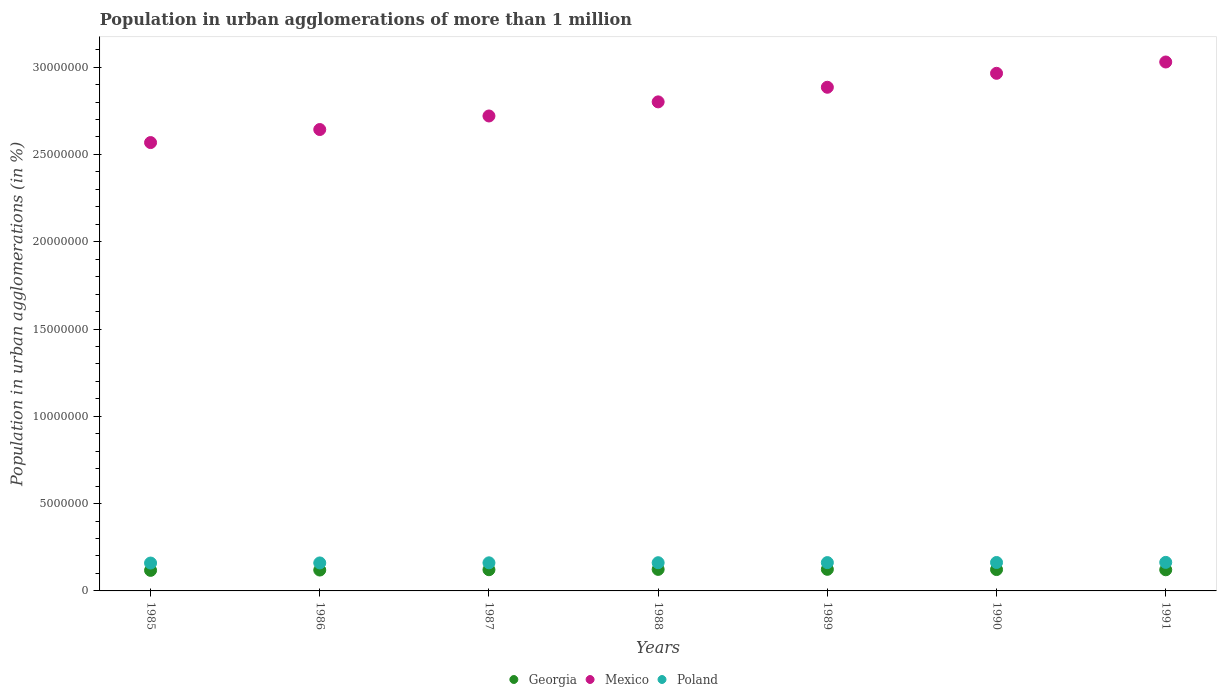How many different coloured dotlines are there?
Keep it short and to the point. 3. What is the population in urban agglomerations in Mexico in 1985?
Your answer should be compact. 2.57e+07. Across all years, what is the maximum population in urban agglomerations in Mexico?
Provide a short and direct response. 3.03e+07. Across all years, what is the minimum population in urban agglomerations in Poland?
Provide a short and direct response. 1.60e+06. In which year was the population in urban agglomerations in Poland maximum?
Your answer should be very brief. 1991. What is the total population in urban agglomerations in Georgia in the graph?
Your answer should be compact. 8.49e+06. What is the difference between the population in urban agglomerations in Mexico in 1988 and that in 1991?
Keep it short and to the point. -2.28e+06. What is the difference between the population in urban agglomerations in Poland in 1989 and the population in urban agglomerations in Mexico in 1987?
Keep it short and to the point. -2.56e+07. What is the average population in urban agglomerations in Poland per year?
Provide a short and direct response. 1.62e+06. In the year 1990, what is the difference between the population in urban agglomerations in Georgia and population in urban agglomerations in Mexico?
Ensure brevity in your answer.  -2.84e+07. What is the ratio of the population in urban agglomerations in Poland in 1989 to that in 1990?
Provide a short and direct response. 1. Is the difference between the population in urban agglomerations in Georgia in 1989 and 1991 greater than the difference between the population in urban agglomerations in Mexico in 1989 and 1991?
Offer a terse response. Yes. What is the difference between the highest and the second highest population in urban agglomerations in Mexico?
Give a very brief answer. 6.48e+05. What is the difference between the highest and the lowest population in urban agglomerations in Georgia?
Your answer should be compact. 5.96e+04. In how many years, is the population in urban agglomerations in Poland greater than the average population in urban agglomerations in Poland taken over all years?
Ensure brevity in your answer.  3. Is the sum of the population in urban agglomerations in Georgia in 1986 and 1989 greater than the maximum population in urban agglomerations in Mexico across all years?
Keep it short and to the point. No. Is it the case that in every year, the sum of the population in urban agglomerations in Poland and population in urban agglomerations in Georgia  is greater than the population in urban agglomerations in Mexico?
Provide a short and direct response. No. Does the population in urban agglomerations in Poland monotonically increase over the years?
Provide a succinct answer. Yes. Is the population in urban agglomerations in Georgia strictly less than the population in urban agglomerations in Poland over the years?
Make the answer very short. Yes. How many dotlines are there?
Ensure brevity in your answer.  3. How many years are there in the graph?
Your response must be concise. 7. Are the values on the major ticks of Y-axis written in scientific E-notation?
Your response must be concise. No. Does the graph contain any zero values?
Your response must be concise. No. Does the graph contain grids?
Offer a very short reply. No. Where does the legend appear in the graph?
Provide a succinct answer. Bottom center. How many legend labels are there?
Your response must be concise. 3. How are the legend labels stacked?
Make the answer very short. Horizontal. What is the title of the graph?
Your answer should be compact. Population in urban agglomerations of more than 1 million. Does "Latin America(developing only)" appear as one of the legend labels in the graph?
Offer a terse response. No. What is the label or title of the X-axis?
Offer a terse response. Years. What is the label or title of the Y-axis?
Your answer should be very brief. Population in urban agglomerations (in %). What is the Population in urban agglomerations (in %) in Georgia in 1985?
Your answer should be compact. 1.18e+06. What is the Population in urban agglomerations (in %) of Mexico in 1985?
Provide a succinct answer. 2.57e+07. What is the Population in urban agglomerations (in %) of Poland in 1985?
Your answer should be very brief. 1.60e+06. What is the Population in urban agglomerations (in %) of Georgia in 1986?
Offer a terse response. 1.20e+06. What is the Population in urban agglomerations (in %) in Mexico in 1986?
Give a very brief answer. 2.64e+07. What is the Population in urban agglomerations (in %) in Poland in 1986?
Offer a terse response. 1.60e+06. What is the Population in urban agglomerations (in %) in Georgia in 1987?
Provide a succinct answer. 1.21e+06. What is the Population in urban agglomerations (in %) of Mexico in 1987?
Provide a succinct answer. 2.72e+07. What is the Population in urban agglomerations (in %) in Poland in 1987?
Your response must be concise. 1.61e+06. What is the Population in urban agglomerations (in %) of Georgia in 1988?
Your response must be concise. 1.23e+06. What is the Population in urban agglomerations (in %) in Mexico in 1988?
Keep it short and to the point. 2.80e+07. What is the Population in urban agglomerations (in %) of Poland in 1988?
Offer a terse response. 1.62e+06. What is the Population in urban agglomerations (in %) of Georgia in 1989?
Keep it short and to the point. 1.24e+06. What is the Population in urban agglomerations (in %) of Mexico in 1989?
Give a very brief answer. 2.88e+07. What is the Population in urban agglomerations (in %) in Poland in 1989?
Give a very brief answer. 1.62e+06. What is the Population in urban agglomerations (in %) of Georgia in 1990?
Make the answer very short. 1.22e+06. What is the Population in urban agglomerations (in %) in Mexico in 1990?
Your response must be concise. 2.96e+07. What is the Population in urban agglomerations (in %) in Poland in 1990?
Provide a succinct answer. 1.63e+06. What is the Population in urban agglomerations (in %) in Georgia in 1991?
Give a very brief answer. 1.21e+06. What is the Population in urban agglomerations (in %) in Mexico in 1991?
Ensure brevity in your answer.  3.03e+07. What is the Population in urban agglomerations (in %) in Poland in 1991?
Your answer should be compact. 1.63e+06. Across all years, what is the maximum Population in urban agglomerations (in %) of Georgia?
Your answer should be compact. 1.24e+06. Across all years, what is the maximum Population in urban agglomerations (in %) in Mexico?
Keep it short and to the point. 3.03e+07. Across all years, what is the maximum Population in urban agglomerations (in %) of Poland?
Make the answer very short. 1.63e+06. Across all years, what is the minimum Population in urban agglomerations (in %) in Georgia?
Offer a terse response. 1.18e+06. Across all years, what is the minimum Population in urban agglomerations (in %) of Mexico?
Make the answer very short. 2.57e+07. Across all years, what is the minimum Population in urban agglomerations (in %) in Poland?
Offer a terse response. 1.60e+06. What is the total Population in urban agglomerations (in %) of Georgia in the graph?
Provide a succinct answer. 8.49e+06. What is the total Population in urban agglomerations (in %) in Mexico in the graph?
Offer a very short reply. 1.96e+08. What is the total Population in urban agglomerations (in %) of Poland in the graph?
Keep it short and to the point. 1.13e+07. What is the difference between the Population in urban agglomerations (in %) in Georgia in 1985 and that in 1986?
Offer a very short reply. -1.83e+04. What is the difference between the Population in urban agglomerations (in %) in Mexico in 1985 and that in 1986?
Give a very brief answer. -7.47e+05. What is the difference between the Population in urban agglomerations (in %) of Poland in 1985 and that in 1986?
Your answer should be compact. -6335. What is the difference between the Population in urban agglomerations (in %) of Georgia in 1985 and that in 1987?
Your answer should be compact. -3.68e+04. What is the difference between the Population in urban agglomerations (in %) of Mexico in 1985 and that in 1987?
Make the answer very short. -1.52e+06. What is the difference between the Population in urban agglomerations (in %) of Poland in 1985 and that in 1987?
Your response must be concise. -1.27e+04. What is the difference between the Population in urban agglomerations (in %) in Georgia in 1985 and that in 1988?
Your response must be concise. -5.56e+04. What is the difference between the Population in urban agglomerations (in %) in Mexico in 1985 and that in 1988?
Ensure brevity in your answer.  -2.33e+06. What is the difference between the Population in urban agglomerations (in %) in Poland in 1985 and that in 1988?
Offer a very short reply. -1.91e+04. What is the difference between the Population in urban agglomerations (in %) of Georgia in 1985 and that in 1989?
Your answer should be very brief. -5.96e+04. What is the difference between the Population in urban agglomerations (in %) in Mexico in 1985 and that in 1989?
Your answer should be very brief. -3.17e+06. What is the difference between the Population in urban agglomerations (in %) in Poland in 1985 and that in 1989?
Make the answer very short. -2.55e+04. What is the difference between the Population in urban agglomerations (in %) in Georgia in 1985 and that in 1990?
Your answer should be compact. -4.65e+04. What is the difference between the Population in urban agglomerations (in %) of Mexico in 1985 and that in 1990?
Offer a terse response. -3.97e+06. What is the difference between the Population in urban agglomerations (in %) in Poland in 1985 and that in 1990?
Give a very brief answer. -3.19e+04. What is the difference between the Population in urban agglomerations (in %) of Georgia in 1985 and that in 1991?
Give a very brief answer. -3.35e+04. What is the difference between the Population in urban agglomerations (in %) of Mexico in 1985 and that in 1991?
Provide a succinct answer. -4.61e+06. What is the difference between the Population in urban agglomerations (in %) in Poland in 1985 and that in 1991?
Your answer should be compact. -3.84e+04. What is the difference between the Population in urban agglomerations (in %) in Georgia in 1986 and that in 1987?
Offer a terse response. -1.85e+04. What is the difference between the Population in urban agglomerations (in %) of Mexico in 1986 and that in 1987?
Your answer should be very brief. -7.76e+05. What is the difference between the Population in urban agglomerations (in %) in Poland in 1986 and that in 1987?
Your answer should be compact. -6361. What is the difference between the Population in urban agglomerations (in %) in Georgia in 1986 and that in 1988?
Provide a succinct answer. -3.74e+04. What is the difference between the Population in urban agglomerations (in %) in Mexico in 1986 and that in 1988?
Make the answer very short. -1.58e+06. What is the difference between the Population in urban agglomerations (in %) in Poland in 1986 and that in 1988?
Make the answer very short. -1.28e+04. What is the difference between the Population in urban agglomerations (in %) of Georgia in 1986 and that in 1989?
Provide a succinct answer. -4.14e+04. What is the difference between the Population in urban agglomerations (in %) in Mexico in 1986 and that in 1989?
Provide a short and direct response. -2.42e+06. What is the difference between the Population in urban agglomerations (in %) of Poland in 1986 and that in 1989?
Offer a terse response. -1.92e+04. What is the difference between the Population in urban agglomerations (in %) in Georgia in 1986 and that in 1990?
Provide a short and direct response. -2.82e+04. What is the difference between the Population in urban agglomerations (in %) of Mexico in 1986 and that in 1990?
Your answer should be compact. -3.22e+06. What is the difference between the Population in urban agglomerations (in %) in Poland in 1986 and that in 1990?
Provide a succinct answer. -2.56e+04. What is the difference between the Population in urban agglomerations (in %) of Georgia in 1986 and that in 1991?
Keep it short and to the point. -1.52e+04. What is the difference between the Population in urban agglomerations (in %) in Mexico in 1986 and that in 1991?
Give a very brief answer. -3.87e+06. What is the difference between the Population in urban agglomerations (in %) in Poland in 1986 and that in 1991?
Give a very brief answer. -3.21e+04. What is the difference between the Population in urban agglomerations (in %) in Georgia in 1987 and that in 1988?
Give a very brief answer. -1.89e+04. What is the difference between the Population in urban agglomerations (in %) in Mexico in 1987 and that in 1988?
Keep it short and to the point. -8.07e+05. What is the difference between the Population in urban agglomerations (in %) in Poland in 1987 and that in 1988?
Offer a terse response. -6394. What is the difference between the Population in urban agglomerations (in %) in Georgia in 1987 and that in 1989?
Provide a short and direct response. -2.28e+04. What is the difference between the Population in urban agglomerations (in %) in Mexico in 1987 and that in 1989?
Provide a succinct answer. -1.64e+06. What is the difference between the Population in urban agglomerations (in %) in Poland in 1987 and that in 1989?
Your response must be concise. -1.28e+04. What is the difference between the Population in urban agglomerations (in %) in Georgia in 1987 and that in 1990?
Ensure brevity in your answer.  -9685. What is the difference between the Population in urban agglomerations (in %) of Mexico in 1987 and that in 1990?
Give a very brief answer. -2.44e+06. What is the difference between the Population in urban agglomerations (in %) of Poland in 1987 and that in 1990?
Offer a terse response. -1.92e+04. What is the difference between the Population in urban agglomerations (in %) in Georgia in 1987 and that in 1991?
Your answer should be compact. 3322. What is the difference between the Population in urban agglomerations (in %) of Mexico in 1987 and that in 1991?
Ensure brevity in your answer.  -3.09e+06. What is the difference between the Population in urban agglomerations (in %) of Poland in 1987 and that in 1991?
Ensure brevity in your answer.  -2.57e+04. What is the difference between the Population in urban agglomerations (in %) in Georgia in 1988 and that in 1989?
Provide a succinct answer. -3980. What is the difference between the Population in urban agglomerations (in %) of Mexico in 1988 and that in 1989?
Your response must be concise. -8.37e+05. What is the difference between the Population in urban agglomerations (in %) of Poland in 1988 and that in 1989?
Make the answer very short. -6402. What is the difference between the Population in urban agglomerations (in %) in Georgia in 1988 and that in 1990?
Your answer should be very brief. 9166. What is the difference between the Population in urban agglomerations (in %) in Mexico in 1988 and that in 1990?
Ensure brevity in your answer.  -1.64e+06. What is the difference between the Population in urban agglomerations (in %) in Poland in 1988 and that in 1990?
Offer a very short reply. -1.28e+04. What is the difference between the Population in urban agglomerations (in %) of Georgia in 1988 and that in 1991?
Ensure brevity in your answer.  2.22e+04. What is the difference between the Population in urban agglomerations (in %) of Mexico in 1988 and that in 1991?
Provide a succinct answer. -2.28e+06. What is the difference between the Population in urban agglomerations (in %) in Poland in 1988 and that in 1991?
Offer a terse response. -1.93e+04. What is the difference between the Population in urban agglomerations (in %) of Georgia in 1989 and that in 1990?
Your answer should be compact. 1.31e+04. What is the difference between the Population in urban agglomerations (in %) of Mexico in 1989 and that in 1990?
Your response must be concise. -7.99e+05. What is the difference between the Population in urban agglomerations (in %) of Poland in 1989 and that in 1990?
Your response must be concise. -6436. What is the difference between the Population in urban agglomerations (in %) in Georgia in 1989 and that in 1991?
Provide a short and direct response. 2.62e+04. What is the difference between the Population in urban agglomerations (in %) of Mexico in 1989 and that in 1991?
Ensure brevity in your answer.  -1.45e+06. What is the difference between the Population in urban agglomerations (in %) of Poland in 1989 and that in 1991?
Your response must be concise. -1.29e+04. What is the difference between the Population in urban agglomerations (in %) in Georgia in 1990 and that in 1991?
Make the answer very short. 1.30e+04. What is the difference between the Population in urban agglomerations (in %) in Mexico in 1990 and that in 1991?
Your answer should be compact. -6.48e+05. What is the difference between the Population in urban agglomerations (in %) of Poland in 1990 and that in 1991?
Ensure brevity in your answer.  -6462. What is the difference between the Population in urban agglomerations (in %) of Georgia in 1985 and the Population in urban agglomerations (in %) of Mexico in 1986?
Keep it short and to the point. -2.52e+07. What is the difference between the Population in urban agglomerations (in %) of Georgia in 1985 and the Population in urban agglomerations (in %) of Poland in 1986?
Provide a succinct answer. -4.25e+05. What is the difference between the Population in urban agglomerations (in %) in Mexico in 1985 and the Population in urban agglomerations (in %) in Poland in 1986?
Your answer should be very brief. 2.41e+07. What is the difference between the Population in urban agglomerations (in %) of Georgia in 1985 and the Population in urban agglomerations (in %) of Mexico in 1987?
Your answer should be very brief. -2.60e+07. What is the difference between the Population in urban agglomerations (in %) of Georgia in 1985 and the Population in urban agglomerations (in %) of Poland in 1987?
Your answer should be compact. -4.32e+05. What is the difference between the Population in urban agglomerations (in %) of Mexico in 1985 and the Population in urban agglomerations (in %) of Poland in 1987?
Your response must be concise. 2.41e+07. What is the difference between the Population in urban agglomerations (in %) in Georgia in 1985 and the Population in urban agglomerations (in %) in Mexico in 1988?
Keep it short and to the point. -2.68e+07. What is the difference between the Population in urban agglomerations (in %) in Georgia in 1985 and the Population in urban agglomerations (in %) in Poland in 1988?
Ensure brevity in your answer.  -4.38e+05. What is the difference between the Population in urban agglomerations (in %) of Mexico in 1985 and the Population in urban agglomerations (in %) of Poland in 1988?
Offer a very short reply. 2.41e+07. What is the difference between the Population in urban agglomerations (in %) in Georgia in 1985 and the Population in urban agglomerations (in %) in Mexico in 1989?
Offer a very short reply. -2.77e+07. What is the difference between the Population in urban agglomerations (in %) in Georgia in 1985 and the Population in urban agglomerations (in %) in Poland in 1989?
Provide a succinct answer. -4.45e+05. What is the difference between the Population in urban agglomerations (in %) of Mexico in 1985 and the Population in urban agglomerations (in %) of Poland in 1989?
Your answer should be very brief. 2.41e+07. What is the difference between the Population in urban agglomerations (in %) in Georgia in 1985 and the Population in urban agglomerations (in %) in Mexico in 1990?
Ensure brevity in your answer.  -2.85e+07. What is the difference between the Population in urban agglomerations (in %) in Georgia in 1985 and the Population in urban agglomerations (in %) in Poland in 1990?
Provide a succinct answer. -4.51e+05. What is the difference between the Population in urban agglomerations (in %) in Mexico in 1985 and the Population in urban agglomerations (in %) in Poland in 1990?
Keep it short and to the point. 2.40e+07. What is the difference between the Population in urban agglomerations (in %) of Georgia in 1985 and the Population in urban agglomerations (in %) of Mexico in 1991?
Provide a short and direct response. -2.91e+07. What is the difference between the Population in urban agglomerations (in %) of Georgia in 1985 and the Population in urban agglomerations (in %) of Poland in 1991?
Provide a short and direct response. -4.57e+05. What is the difference between the Population in urban agglomerations (in %) in Mexico in 1985 and the Population in urban agglomerations (in %) in Poland in 1991?
Offer a terse response. 2.40e+07. What is the difference between the Population in urban agglomerations (in %) in Georgia in 1986 and the Population in urban agglomerations (in %) in Mexico in 1987?
Offer a very short reply. -2.60e+07. What is the difference between the Population in urban agglomerations (in %) in Georgia in 1986 and the Population in urban agglomerations (in %) in Poland in 1987?
Make the answer very short. -4.13e+05. What is the difference between the Population in urban agglomerations (in %) in Mexico in 1986 and the Population in urban agglomerations (in %) in Poland in 1987?
Make the answer very short. 2.48e+07. What is the difference between the Population in urban agglomerations (in %) of Georgia in 1986 and the Population in urban agglomerations (in %) of Mexico in 1988?
Make the answer very short. -2.68e+07. What is the difference between the Population in urban agglomerations (in %) of Georgia in 1986 and the Population in urban agglomerations (in %) of Poland in 1988?
Provide a short and direct response. -4.20e+05. What is the difference between the Population in urban agglomerations (in %) of Mexico in 1986 and the Population in urban agglomerations (in %) of Poland in 1988?
Your answer should be compact. 2.48e+07. What is the difference between the Population in urban agglomerations (in %) in Georgia in 1986 and the Population in urban agglomerations (in %) in Mexico in 1989?
Make the answer very short. -2.76e+07. What is the difference between the Population in urban agglomerations (in %) of Georgia in 1986 and the Population in urban agglomerations (in %) of Poland in 1989?
Your answer should be very brief. -4.26e+05. What is the difference between the Population in urban agglomerations (in %) of Mexico in 1986 and the Population in urban agglomerations (in %) of Poland in 1989?
Provide a short and direct response. 2.48e+07. What is the difference between the Population in urban agglomerations (in %) in Georgia in 1986 and the Population in urban agglomerations (in %) in Mexico in 1990?
Keep it short and to the point. -2.84e+07. What is the difference between the Population in urban agglomerations (in %) in Georgia in 1986 and the Population in urban agglomerations (in %) in Poland in 1990?
Your answer should be compact. -4.33e+05. What is the difference between the Population in urban agglomerations (in %) of Mexico in 1986 and the Population in urban agglomerations (in %) of Poland in 1990?
Provide a short and direct response. 2.48e+07. What is the difference between the Population in urban agglomerations (in %) of Georgia in 1986 and the Population in urban agglomerations (in %) of Mexico in 1991?
Your answer should be very brief. -2.91e+07. What is the difference between the Population in urban agglomerations (in %) of Georgia in 1986 and the Population in urban agglomerations (in %) of Poland in 1991?
Make the answer very short. -4.39e+05. What is the difference between the Population in urban agglomerations (in %) in Mexico in 1986 and the Population in urban agglomerations (in %) in Poland in 1991?
Ensure brevity in your answer.  2.48e+07. What is the difference between the Population in urban agglomerations (in %) in Georgia in 1987 and the Population in urban agglomerations (in %) in Mexico in 1988?
Your response must be concise. -2.68e+07. What is the difference between the Population in urban agglomerations (in %) in Georgia in 1987 and the Population in urban agglomerations (in %) in Poland in 1988?
Keep it short and to the point. -4.01e+05. What is the difference between the Population in urban agglomerations (in %) in Mexico in 1987 and the Population in urban agglomerations (in %) in Poland in 1988?
Your answer should be very brief. 2.56e+07. What is the difference between the Population in urban agglomerations (in %) of Georgia in 1987 and the Population in urban agglomerations (in %) of Mexico in 1989?
Ensure brevity in your answer.  -2.76e+07. What is the difference between the Population in urban agglomerations (in %) in Georgia in 1987 and the Population in urban agglomerations (in %) in Poland in 1989?
Provide a short and direct response. -4.08e+05. What is the difference between the Population in urban agglomerations (in %) in Mexico in 1987 and the Population in urban agglomerations (in %) in Poland in 1989?
Provide a short and direct response. 2.56e+07. What is the difference between the Population in urban agglomerations (in %) in Georgia in 1987 and the Population in urban agglomerations (in %) in Mexico in 1990?
Ensure brevity in your answer.  -2.84e+07. What is the difference between the Population in urban agglomerations (in %) of Georgia in 1987 and the Population in urban agglomerations (in %) of Poland in 1990?
Provide a short and direct response. -4.14e+05. What is the difference between the Population in urban agglomerations (in %) in Mexico in 1987 and the Population in urban agglomerations (in %) in Poland in 1990?
Your response must be concise. 2.56e+07. What is the difference between the Population in urban agglomerations (in %) of Georgia in 1987 and the Population in urban agglomerations (in %) of Mexico in 1991?
Keep it short and to the point. -2.91e+07. What is the difference between the Population in urban agglomerations (in %) of Georgia in 1987 and the Population in urban agglomerations (in %) of Poland in 1991?
Offer a terse response. -4.21e+05. What is the difference between the Population in urban agglomerations (in %) in Mexico in 1987 and the Population in urban agglomerations (in %) in Poland in 1991?
Make the answer very short. 2.56e+07. What is the difference between the Population in urban agglomerations (in %) in Georgia in 1988 and the Population in urban agglomerations (in %) in Mexico in 1989?
Your answer should be compact. -2.76e+07. What is the difference between the Population in urban agglomerations (in %) in Georgia in 1988 and the Population in urban agglomerations (in %) in Poland in 1989?
Make the answer very short. -3.89e+05. What is the difference between the Population in urban agglomerations (in %) in Mexico in 1988 and the Population in urban agglomerations (in %) in Poland in 1989?
Offer a terse response. 2.64e+07. What is the difference between the Population in urban agglomerations (in %) of Georgia in 1988 and the Population in urban agglomerations (in %) of Mexico in 1990?
Your response must be concise. -2.84e+07. What is the difference between the Population in urban agglomerations (in %) of Georgia in 1988 and the Population in urban agglomerations (in %) of Poland in 1990?
Your answer should be very brief. -3.95e+05. What is the difference between the Population in urban agglomerations (in %) of Mexico in 1988 and the Population in urban agglomerations (in %) of Poland in 1990?
Ensure brevity in your answer.  2.64e+07. What is the difference between the Population in urban agglomerations (in %) in Georgia in 1988 and the Population in urban agglomerations (in %) in Mexico in 1991?
Provide a short and direct response. -2.91e+07. What is the difference between the Population in urban agglomerations (in %) of Georgia in 1988 and the Population in urban agglomerations (in %) of Poland in 1991?
Your answer should be very brief. -4.02e+05. What is the difference between the Population in urban agglomerations (in %) of Mexico in 1988 and the Population in urban agglomerations (in %) of Poland in 1991?
Provide a short and direct response. 2.64e+07. What is the difference between the Population in urban agglomerations (in %) of Georgia in 1989 and the Population in urban agglomerations (in %) of Mexico in 1990?
Offer a very short reply. -2.84e+07. What is the difference between the Population in urban agglomerations (in %) in Georgia in 1989 and the Population in urban agglomerations (in %) in Poland in 1990?
Offer a terse response. -3.91e+05. What is the difference between the Population in urban agglomerations (in %) in Mexico in 1989 and the Population in urban agglomerations (in %) in Poland in 1990?
Your response must be concise. 2.72e+07. What is the difference between the Population in urban agglomerations (in %) of Georgia in 1989 and the Population in urban agglomerations (in %) of Mexico in 1991?
Your response must be concise. -2.91e+07. What is the difference between the Population in urban agglomerations (in %) of Georgia in 1989 and the Population in urban agglomerations (in %) of Poland in 1991?
Make the answer very short. -3.98e+05. What is the difference between the Population in urban agglomerations (in %) in Mexico in 1989 and the Population in urban agglomerations (in %) in Poland in 1991?
Provide a short and direct response. 2.72e+07. What is the difference between the Population in urban agglomerations (in %) of Georgia in 1990 and the Population in urban agglomerations (in %) of Mexico in 1991?
Provide a succinct answer. -2.91e+07. What is the difference between the Population in urban agglomerations (in %) of Georgia in 1990 and the Population in urban agglomerations (in %) of Poland in 1991?
Offer a terse response. -4.11e+05. What is the difference between the Population in urban agglomerations (in %) in Mexico in 1990 and the Population in urban agglomerations (in %) in Poland in 1991?
Your answer should be compact. 2.80e+07. What is the average Population in urban agglomerations (in %) of Georgia per year?
Provide a succinct answer. 1.21e+06. What is the average Population in urban agglomerations (in %) of Mexico per year?
Offer a very short reply. 2.80e+07. What is the average Population in urban agglomerations (in %) in Poland per year?
Make the answer very short. 1.62e+06. In the year 1985, what is the difference between the Population in urban agglomerations (in %) of Georgia and Population in urban agglomerations (in %) of Mexico?
Your answer should be compact. -2.45e+07. In the year 1985, what is the difference between the Population in urban agglomerations (in %) in Georgia and Population in urban agglomerations (in %) in Poland?
Keep it short and to the point. -4.19e+05. In the year 1985, what is the difference between the Population in urban agglomerations (in %) of Mexico and Population in urban agglomerations (in %) of Poland?
Make the answer very short. 2.41e+07. In the year 1986, what is the difference between the Population in urban agglomerations (in %) of Georgia and Population in urban agglomerations (in %) of Mexico?
Ensure brevity in your answer.  -2.52e+07. In the year 1986, what is the difference between the Population in urban agglomerations (in %) in Georgia and Population in urban agglomerations (in %) in Poland?
Keep it short and to the point. -4.07e+05. In the year 1986, what is the difference between the Population in urban agglomerations (in %) of Mexico and Population in urban agglomerations (in %) of Poland?
Your response must be concise. 2.48e+07. In the year 1987, what is the difference between the Population in urban agglomerations (in %) of Georgia and Population in urban agglomerations (in %) of Mexico?
Keep it short and to the point. -2.60e+07. In the year 1987, what is the difference between the Population in urban agglomerations (in %) of Georgia and Population in urban agglomerations (in %) of Poland?
Offer a very short reply. -3.95e+05. In the year 1987, what is the difference between the Population in urban agglomerations (in %) of Mexico and Population in urban agglomerations (in %) of Poland?
Make the answer very short. 2.56e+07. In the year 1988, what is the difference between the Population in urban agglomerations (in %) of Georgia and Population in urban agglomerations (in %) of Mexico?
Provide a short and direct response. -2.68e+07. In the year 1988, what is the difference between the Population in urban agglomerations (in %) in Georgia and Population in urban agglomerations (in %) in Poland?
Make the answer very short. -3.82e+05. In the year 1988, what is the difference between the Population in urban agglomerations (in %) in Mexico and Population in urban agglomerations (in %) in Poland?
Give a very brief answer. 2.64e+07. In the year 1989, what is the difference between the Population in urban agglomerations (in %) in Georgia and Population in urban agglomerations (in %) in Mexico?
Offer a very short reply. -2.76e+07. In the year 1989, what is the difference between the Population in urban agglomerations (in %) of Georgia and Population in urban agglomerations (in %) of Poland?
Your answer should be compact. -3.85e+05. In the year 1989, what is the difference between the Population in urban agglomerations (in %) in Mexico and Population in urban agglomerations (in %) in Poland?
Keep it short and to the point. 2.72e+07. In the year 1990, what is the difference between the Population in urban agglomerations (in %) in Georgia and Population in urban agglomerations (in %) in Mexico?
Give a very brief answer. -2.84e+07. In the year 1990, what is the difference between the Population in urban agglomerations (in %) in Georgia and Population in urban agglomerations (in %) in Poland?
Your answer should be very brief. -4.04e+05. In the year 1990, what is the difference between the Population in urban agglomerations (in %) of Mexico and Population in urban agglomerations (in %) of Poland?
Keep it short and to the point. 2.80e+07. In the year 1991, what is the difference between the Population in urban agglomerations (in %) in Georgia and Population in urban agglomerations (in %) in Mexico?
Your answer should be very brief. -2.91e+07. In the year 1991, what is the difference between the Population in urban agglomerations (in %) in Georgia and Population in urban agglomerations (in %) in Poland?
Your answer should be compact. -4.24e+05. In the year 1991, what is the difference between the Population in urban agglomerations (in %) in Mexico and Population in urban agglomerations (in %) in Poland?
Offer a very short reply. 2.87e+07. What is the ratio of the Population in urban agglomerations (in %) in Georgia in 1985 to that in 1986?
Offer a very short reply. 0.98. What is the ratio of the Population in urban agglomerations (in %) of Mexico in 1985 to that in 1986?
Provide a short and direct response. 0.97. What is the ratio of the Population in urban agglomerations (in %) in Poland in 1985 to that in 1986?
Provide a short and direct response. 1. What is the ratio of the Population in urban agglomerations (in %) of Georgia in 1985 to that in 1987?
Ensure brevity in your answer.  0.97. What is the ratio of the Population in urban agglomerations (in %) of Mexico in 1985 to that in 1987?
Offer a terse response. 0.94. What is the ratio of the Population in urban agglomerations (in %) in Georgia in 1985 to that in 1988?
Your answer should be compact. 0.95. What is the ratio of the Population in urban agglomerations (in %) of Mexico in 1985 to that in 1988?
Your answer should be very brief. 0.92. What is the ratio of the Population in urban agglomerations (in %) of Poland in 1985 to that in 1988?
Make the answer very short. 0.99. What is the ratio of the Population in urban agglomerations (in %) of Georgia in 1985 to that in 1989?
Your answer should be compact. 0.95. What is the ratio of the Population in urban agglomerations (in %) in Mexico in 1985 to that in 1989?
Offer a terse response. 0.89. What is the ratio of the Population in urban agglomerations (in %) in Poland in 1985 to that in 1989?
Provide a short and direct response. 0.98. What is the ratio of the Population in urban agglomerations (in %) in Georgia in 1985 to that in 1990?
Your response must be concise. 0.96. What is the ratio of the Population in urban agglomerations (in %) of Mexico in 1985 to that in 1990?
Make the answer very short. 0.87. What is the ratio of the Population in urban agglomerations (in %) of Poland in 1985 to that in 1990?
Your response must be concise. 0.98. What is the ratio of the Population in urban agglomerations (in %) in Georgia in 1985 to that in 1991?
Provide a short and direct response. 0.97. What is the ratio of the Population in urban agglomerations (in %) in Mexico in 1985 to that in 1991?
Your answer should be very brief. 0.85. What is the ratio of the Population in urban agglomerations (in %) of Poland in 1985 to that in 1991?
Make the answer very short. 0.98. What is the ratio of the Population in urban agglomerations (in %) of Georgia in 1986 to that in 1987?
Offer a very short reply. 0.98. What is the ratio of the Population in urban agglomerations (in %) of Mexico in 1986 to that in 1987?
Provide a short and direct response. 0.97. What is the ratio of the Population in urban agglomerations (in %) in Poland in 1986 to that in 1987?
Your answer should be compact. 1. What is the ratio of the Population in urban agglomerations (in %) of Georgia in 1986 to that in 1988?
Your response must be concise. 0.97. What is the ratio of the Population in urban agglomerations (in %) in Mexico in 1986 to that in 1988?
Keep it short and to the point. 0.94. What is the ratio of the Population in urban agglomerations (in %) in Georgia in 1986 to that in 1989?
Provide a short and direct response. 0.97. What is the ratio of the Population in urban agglomerations (in %) in Mexico in 1986 to that in 1989?
Ensure brevity in your answer.  0.92. What is the ratio of the Population in urban agglomerations (in %) in Georgia in 1986 to that in 1990?
Offer a terse response. 0.98. What is the ratio of the Population in urban agglomerations (in %) of Mexico in 1986 to that in 1990?
Your answer should be very brief. 0.89. What is the ratio of the Population in urban agglomerations (in %) of Poland in 1986 to that in 1990?
Offer a terse response. 0.98. What is the ratio of the Population in urban agglomerations (in %) in Georgia in 1986 to that in 1991?
Your answer should be compact. 0.99. What is the ratio of the Population in urban agglomerations (in %) of Mexico in 1986 to that in 1991?
Make the answer very short. 0.87. What is the ratio of the Population in urban agglomerations (in %) of Poland in 1986 to that in 1991?
Provide a succinct answer. 0.98. What is the ratio of the Population in urban agglomerations (in %) in Georgia in 1987 to that in 1988?
Give a very brief answer. 0.98. What is the ratio of the Population in urban agglomerations (in %) in Mexico in 1987 to that in 1988?
Provide a succinct answer. 0.97. What is the ratio of the Population in urban agglomerations (in %) in Georgia in 1987 to that in 1989?
Your response must be concise. 0.98. What is the ratio of the Population in urban agglomerations (in %) of Mexico in 1987 to that in 1989?
Your answer should be compact. 0.94. What is the ratio of the Population in urban agglomerations (in %) in Mexico in 1987 to that in 1990?
Provide a succinct answer. 0.92. What is the ratio of the Population in urban agglomerations (in %) of Poland in 1987 to that in 1990?
Keep it short and to the point. 0.99. What is the ratio of the Population in urban agglomerations (in %) of Mexico in 1987 to that in 1991?
Give a very brief answer. 0.9. What is the ratio of the Population in urban agglomerations (in %) of Poland in 1987 to that in 1991?
Offer a very short reply. 0.98. What is the ratio of the Population in urban agglomerations (in %) of Poland in 1988 to that in 1989?
Ensure brevity in your answer.  1. What is the ratio of the Population in urban agglomerations (in %) in Georgia in 1988 to that in 1990?
Your response must be concise. 1.01. What is the ratio of the Population in urban agglomerations (in %) of Mexico in 1988 to that in 1990?
Give a very brief answer. 0.94. What is the ratio of the Population in urban agglomerations (in %) of Georgia in 1988 to that in 1991?
Give a very brief answer. 1.02. What is the ratio of the Population in urban agglomerations (in %) in Mexico in 1988 to that in 1991?
Your answer should be compact. 0.92. What is the ratio of the Population in urban agglomerations (in %) of Poland in 1988 to that in 1991?
Keep it short and to the point. 0.99. What is the ratio of the Population in urban agglomerations (in %) of Georgia in 1989 to that in 1990?
Your answer should be very brief. 1.01. What is the ratio of the Population in urban agglomerations (in %) in Mexico in 1989 to that in 1990?
Keep it short and to the point. 0.97. What is the ratio of the Population in urban agglomerations (in %) in Poland in 1989 to that in 1990?
Provide a succinct answer. 1. What is the ratio of the Population in urban agglomerations (in %) of Georgia in 1989 to that in 1991?
Ensure brevity in your answer.  1.02. What is the ratio of the Population in urban agglomerations (in %) in Mexico in 1989 to that in 1991?
Your answer should be compact. 0.95. What is the ratio of the Population in urban agglomerations (in %) in Georgia in 1990 to that in 1991?
Provide a succinct answer. 1.01. What is the ratio of the Population in urban agglomerations (in %) in Mexico in 1990 to that in 1991?
Offer a terse response. 0.98. What is the ratio of the Population in urban agglomerations (in %) of Poland in 1990 to that in 1991?
Your answer should be very brief. 1. What is the difference between the highest and the second highest Population in urban agglomerations (in %) of Georgia?
Ensure brevity in your answer.  3980. What is the difference between the highest and the second highest Population in urban agglomerations (in %) in Mexico?
Make the answer very short. 6.48e+05. What is the difference between the highest and the second highest Population in urban agglomerations (in %) of Poland?
Keep it short and to the point. 6462. What is the difference between the highest and the lowest Population in urban agglomerations (in %) of Georgia?
Your answer should be very brief. 5.96e+04. What is the difference between the highest and the lowest Population in urban agglomerations (in %) in Mexico?
Ensure brevity in your answer.  4.61e+06. What is the difference between the highest and the lowest Population in urban agglomerations (in %) in Poland?
Ensure brevity in your answer.  3.84e+04. 